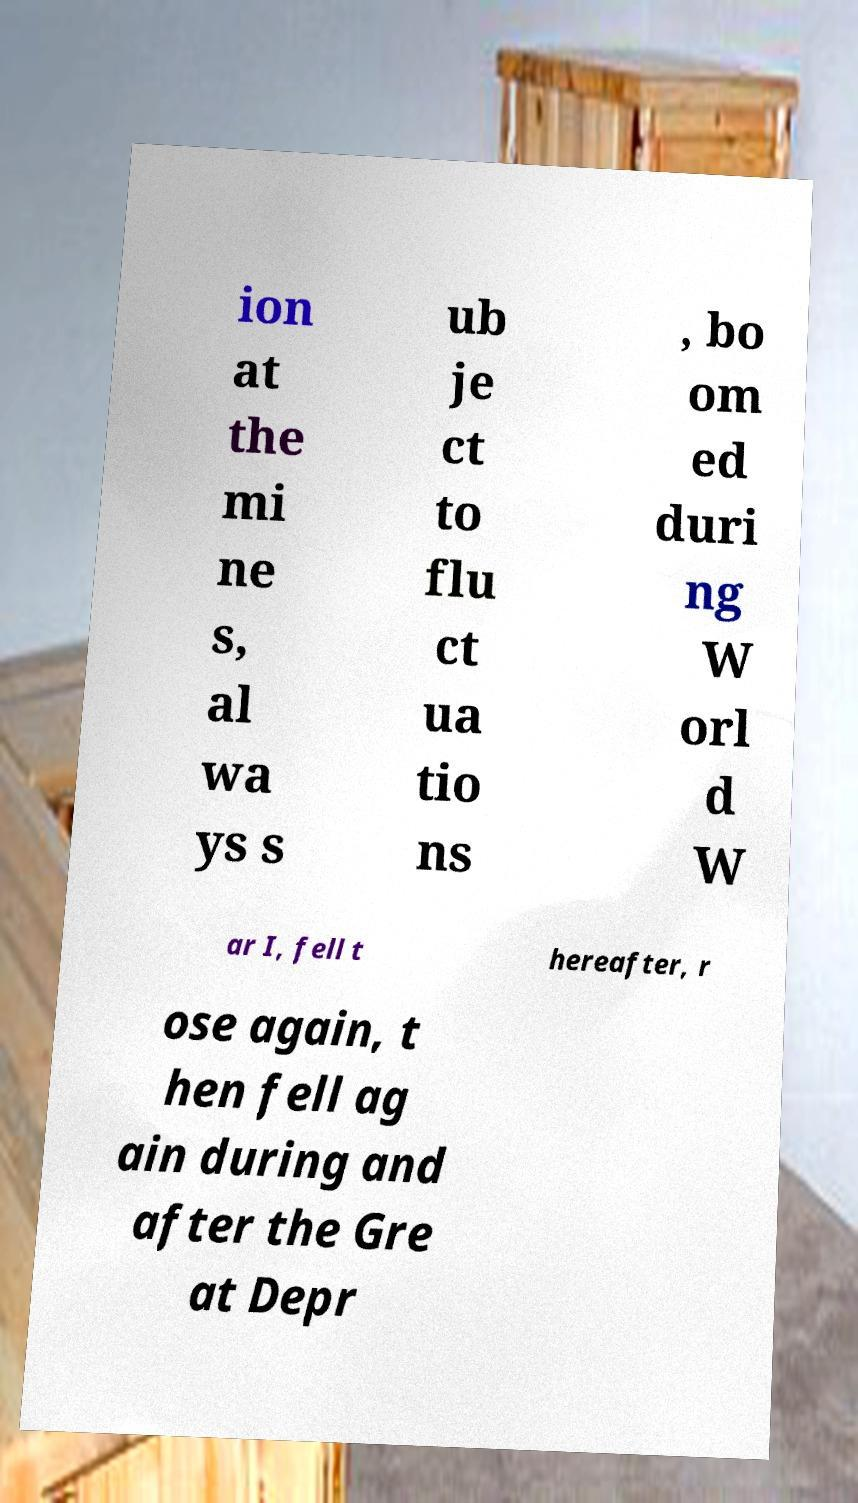Could you assist in decoding the text presented in this image and type it out clearly? ion at the mi ne s, al wa ys s ub je ct to flu ct ua tio ns , bo om ed duri ng W orl d W ar I, fell t hereafter, r ose again, t hen fell ag ain during and after the Gre at Depr 